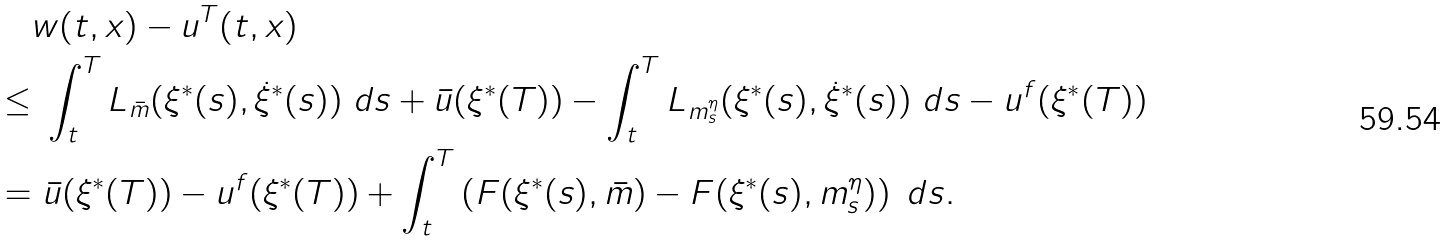Convert formula to latex. <formula><loc_0><loc_0><loc_500><loc_500>& w ( t , x ) - u ^ { T } ( t , x ) \\ \leq & \ \int _ { t } ^ { T } { L _ { \bar { m } } ( \xi ^ { * } ( s ) , \dot { \xi } ^ { * } ( s ) ) \ d s } + \bar { u } ( \xi ^ { * } ( T ) ) - \int _ { t } ^ { T } { L _ { m ^ { \eta } _ { s } } ( \xi ^ { * } ( s ) , \dot { \xi } ^ { * } ( s ) ) \ d s } - u ^ { f } ( \xi ^ { * } ( T ) ) \\ = & \ \bar { u } ( \xi ^ { * } ( T ) ) - u ^ { f } ( \xi ^ { * } ( T ) ) + \int _ { t } ^ { T } { \left ( F ( \xi ^ { * } ( s ) , \bar { m } ) - F ( \xi ^ { * } ( s ) , m ^ { \eta } _ { s } ) \right ) \ d s } .</formula> 